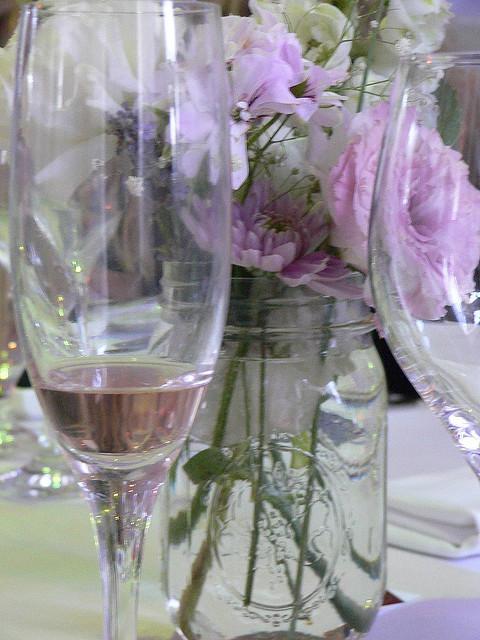How many drinking glasses are visible?
Give a very brief answer. 2. How many vases are in the photo?
Give a very brief answer. 1. How many wine glasses are there?
Give a very brief answer. 2. 